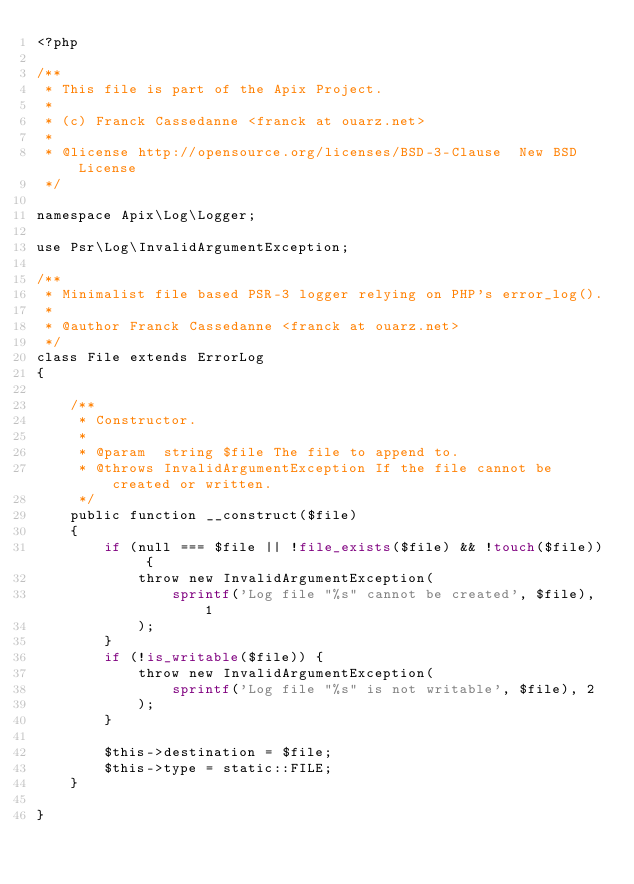Convert code to text. <code><loc_0><loc_0><loc_500><loc_500><_PHP_><?php

/**
 * This file is part of the Apix Project.
 *
 * (c) Franck Cassedanne <franck at ouarz.net>
 *
 * @license http://opensource.org/licenses/BSD-3-Clause  New BSD License
 */

namespace Apix\Log\Logger;

use Psr\Log\InvalidArgumentException;

/**
 * Minimalist file based PSR-3 logger relying on PHP's error_log().
 *
 * @author Franck Cassedanne <franck at ouarz.net>
 */
class File extends ErrorLog
{

    /**
     * Constructor.
     *
     * @param  string $file The file to append to.
     * @throws InvalidArgumentException If the file cannot be created or written.
     */
    public function __construct($file)
    {
        if (null === $file || !file_exists($file) && !touch($file)) {
            throw new InvalidArgumentException(
                sprintf('Log file "%s" cannot be created', $file), 1
            );
        }
        if (!is_writable($file)) {
            throw new InvalidArgumentException(
                sprintf('Log file "%s" is not writable', $file), 2
            );
        }

        $this->destination = $file;
        $this->type = static::FILE;
    }

}
</code> 